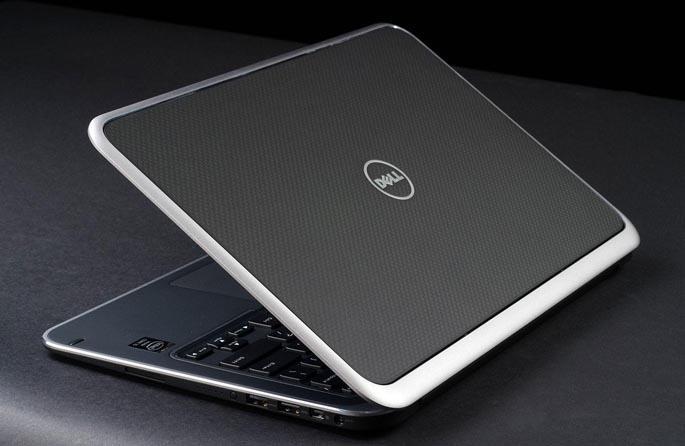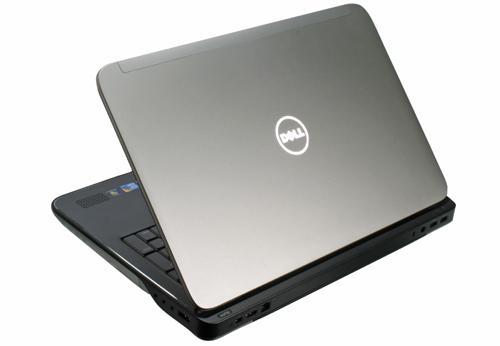The first image is the image on the left, the second image is the image on the right. Evaluate the accuracy of this statement regarding the images: "Each image contains only one laptop, and all laptops are open at less than a 90-degree angle and facing the same general direction.". Is it true? Answer yes or no. Yes. The first image is the image on the left, the second image is the image on the right. Considering the images on both sides, is "The computer screen is visible in at least one of the images." valid? Answer yes or no. No. 